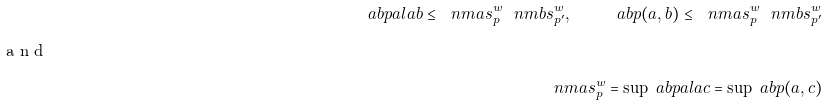Convert formula to latex. <formula><loc_0><loc_0><loc_500><loc_500>\ a b p { a l a b } \leq \ n m a { s ^ { w } _ { p } } \ n m b { s ^ { w } _ { p ^ { \prime } } } , \quad \ a b p { ( a , b ) } \leq \ n m a { s ^ { w } _ { p } } \ n m b { s ^ { w } _ { p ^ { \prime } } } \intertext { a n d } \ n m a { s ^ { w } _ { p } } = \sup \ a b p { a l a c } = \sup \ a b p { ( a , c ) }</formula> 